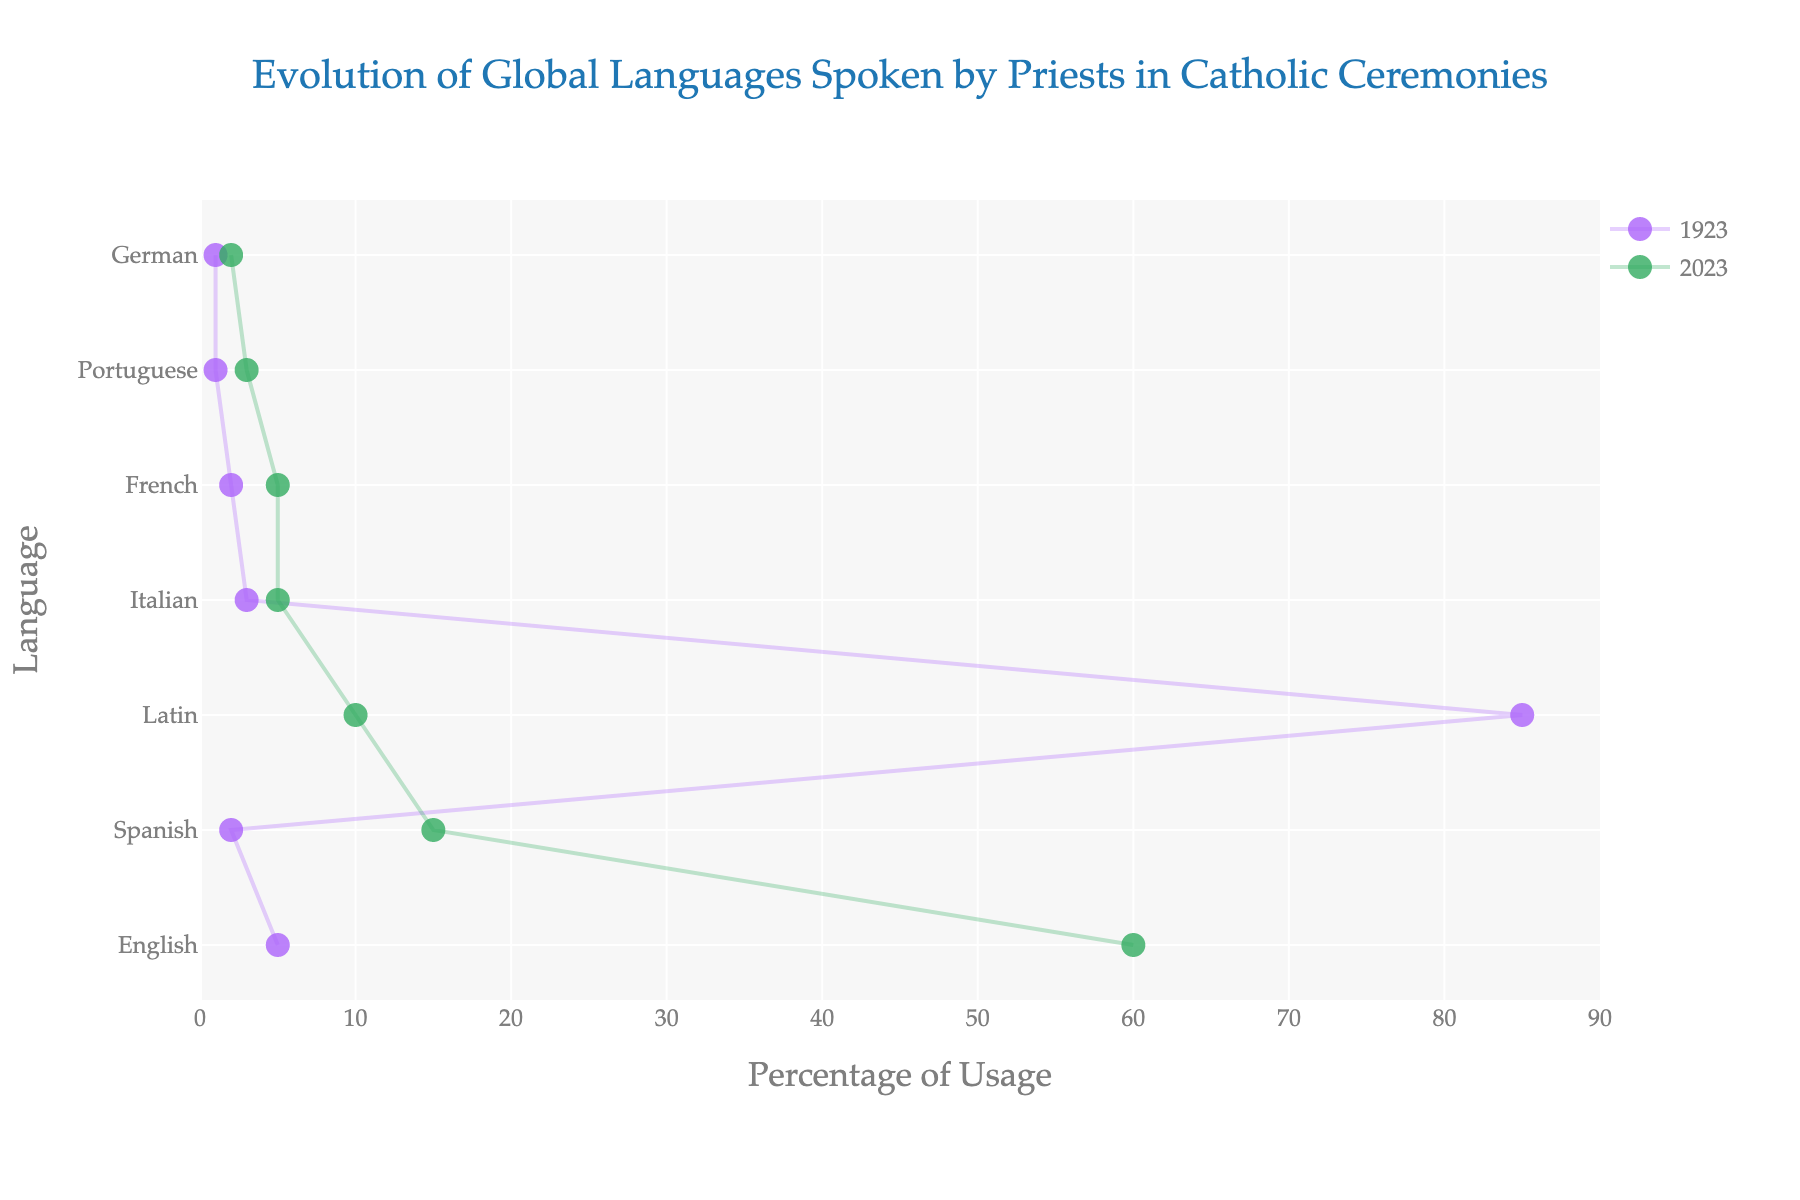What's the title of the plot? The title of the plot is located at the top center of the figure. It reads: "Evolution of Global Languages Spoken by Priests in Catholic Ceremonies."
Answer: Evolution of Global Languages Spoken by Priests in Catholic Ceremonies Which language had the highest percentage of usage in 1923? By looking at the left ends of the dumbbells, which represent the year 1923, Latin had the highest percentage of usage at 85%.
Answer: Latin How does the usage of English compare between 1923 and 2023? To compare the two years for English, we compare the position of the markers for 1923 and 2023. English grew from 5% in 1923 to 60% in 2023. This means the usage increased by 55 percentage points.
Answer: English increased by 55 percentage points What is the total change in percentage usage of Latin from 1923 to 2023? To find the total change, we subtract the 2023 percentage from the 1923 percentage for Latin: 85% - 10% = 75%.
Answer: 75% Which languages had an increase in usage from 1923 to 2023? To determine which languages had an increase, look for languages where the 2023 marker is to the right of the 1923 marker. The languages are English, Spanish, Portuguese, and German.
Answer: English, Spanish, Portuguese, and German Between Spanish and French, which language had a higher percentage change in usage from 1923 to 2023? The percentage change for each language is calculated by subtracting the 1923 percentage from the 2023 percentage. Spanish changed from 2% to 15% (a 13 percentage point increase), while French changed from 2% to 5% (a 3 percentage point increase). Thus, Spanish had a higher percentage change.
Answer: Spanish What is the average percentage usage of Italian and French in 2023? To find the average, add the percentages of Italian and French for 2023 and divide by 2. For 2023, Italian is 5% and French is 5%, so (5 + 5) / 2 = 5%.
Answer: 5% How many languages were used by priests in both 1923 and 2023? Count the number of rows in the data table, as each row represents a language used in both years. There are 7 languages listed.
Answer: 7 Which language had the smallest percentage change in usage from 1923 to 2023? The smallest percentage change is found by taking the absolute value of the difference between 1923 and 2023 for each language. German changed from 1% to 2% which is a 1 percentage point increase, the smallest change.
Answer: German Which language had the second highest usage in 2023? By observing the position of the markers for 2023, English had the highest usage. The next highest percentage is for Spanish at 15%.
Answer: Spanish 